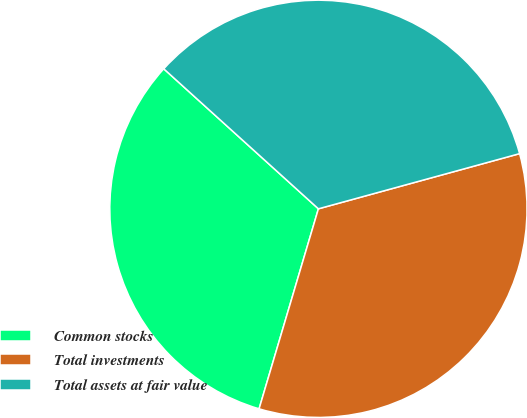Convert chart to OTSL. <chart><loc_0><loc_0><loc_500><loc_500><pie_chart><fcel>Common stocks<fcel>Total investments<fcel>Total assets at fair value<nl><fcel>32.12%<fcel>33.85%<fcel>34.03%<nl></chart> 